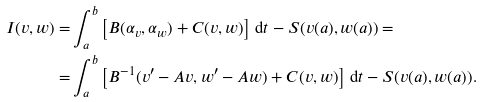<formula> <loc_0><loc_0><loc_500><loc_500>I ( v , w ) = & \int _ { a } ^ { b } \left [ B ( \alpha _ { v } , \alpha _ { w } ) + C ( v , w ) \right ] \, \mathrm d t - S ( v ( a ) , w ( a ) ) = \\ = & \int _ { a } ^ { b } \left [ B ^ { - 1 } ( v ^ { \prime } - A v , w ^ { \prime } - A w ) + C ( v , w ) \right ] \, \mathrm d t - S ( v ( a ) , w ( a ) ) .</formula> 